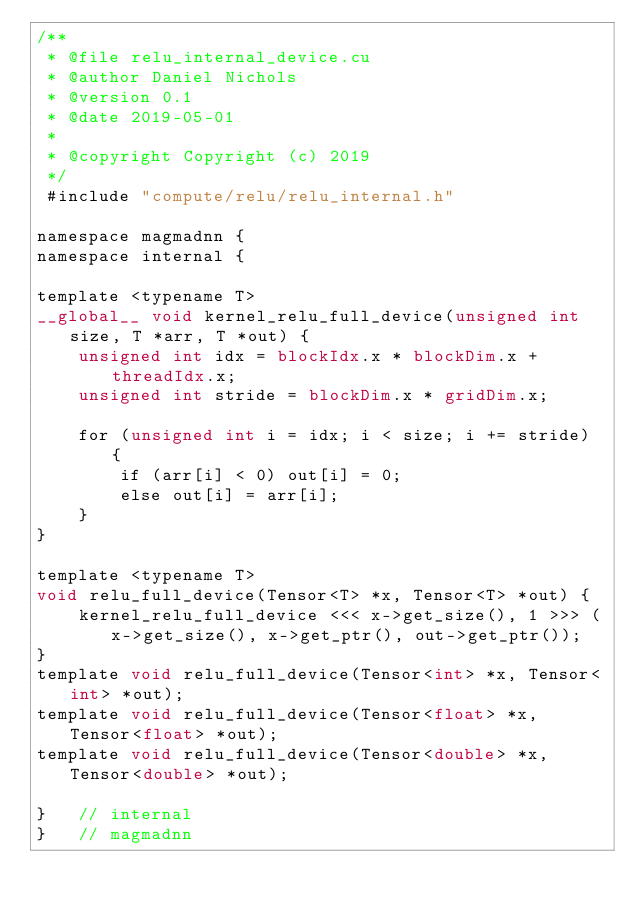Convert code to text. <code><loc_0><loc_0><loc_500><loc_500><_Cuda_>/**
 * @file relu_internal_device.cu
 * @author Daniel Nichols
 * @version 0.1
 * @date 2019-05-01
 * 
 * @copyright Copyright (c) 2019
 */
 #include "compute/relu/relu_internal.h"

namespace magmadnn {
namespace internal {

template <typename T>
__global__ void kernel_relu_full_device(unsigned int size, T *arr, T *out) {
    unsigned int idx = blockIdx.x * blockDim.x + threadIdx.x;
    unsigned int stride = blockDim.x * gridDim.x;
    
    for (unsigned int i = idx; i < size; i += stride) {
        if (arr[i] < 0) out[i] = 0;
        else out[i] = arr[i];
    }
}

template <typename T>
void relu_full_device(Tensor<T> *x, Tensor<T> *out) {
    kernel_relu_full_device <<< x->get_size(), 1 >>> (x->get_size(), x->get_ptr(), out->get_ptr());
}
template void relu_full_device(Tensor<int> *x, Tensor<int> *out);
template void relu_full_device(Tensor<float> *x, Tensor<float> *out);
template void relu_full_device(Tensor<double> *x, Tensor<double> *out);

}   // internal
}   // magmadnn</code> 